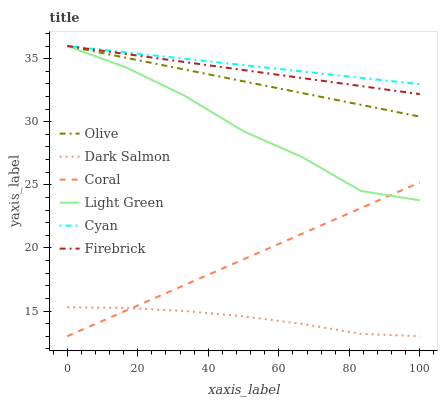Does Dark Salmon have the minimum area under the curve?
Answer yes or no. Yes. Does Light Green have the minimum area under the curve?
Answer yes or no. No. Does Light Green have the maximum area under the curve?
Answer yes or no. No. Is Dark Salmon the smoothest?
Answer yes or no. No. Is Dark Salmon the roughest?
Answer yes or no. No. Does Light Green have the lowest value?
Answer yes or no. No. Does Dark Salmon have the highest value?
Answer yes or no. No. Is Dark Salmon less than Cyan?
Answer yes or no. Yes. Is Olive greater than Dark Salmon?
Answer yes or no. Yes. Does Dark Salmon intersect Cyan?
Answer yes or no. No. 